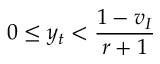<formula> <loc_0><loc_0><loc_500><loc_500>0 \leq y _ { t } < \frac { 1 - v _ { I } } { r + 1 }</formula> 